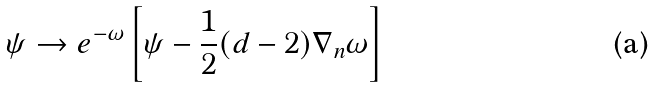<formula> <loc_0><loc_0><loc_500><loc_500>\psi \rightarrow e ^ { - \omega } \left [ \psi - \frac { 1 } { 2 } ( d - 2 ) \nabla _ { n } \omega \right ]</formula> 